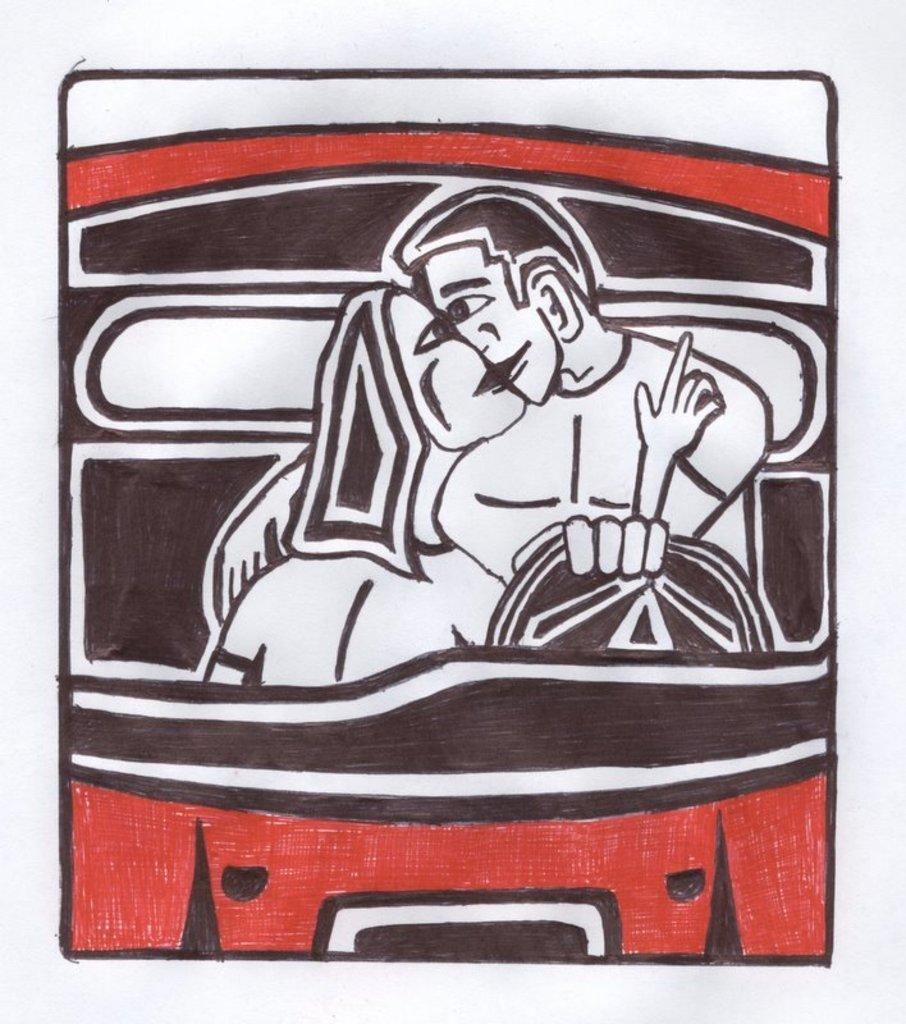What is present on the wall in the image? There is a poster in the image. What can be seen on the poster? The poster has an animated image. What is happening in the animated image? The animated image features two persons sitting on the seats of a vehicle. How many eggs are visible in the image? There are no eggs present in the image. What type of gun is being used by the persons in the image? There is no gun present in the image; the two persons are sitting in a vehicle. 